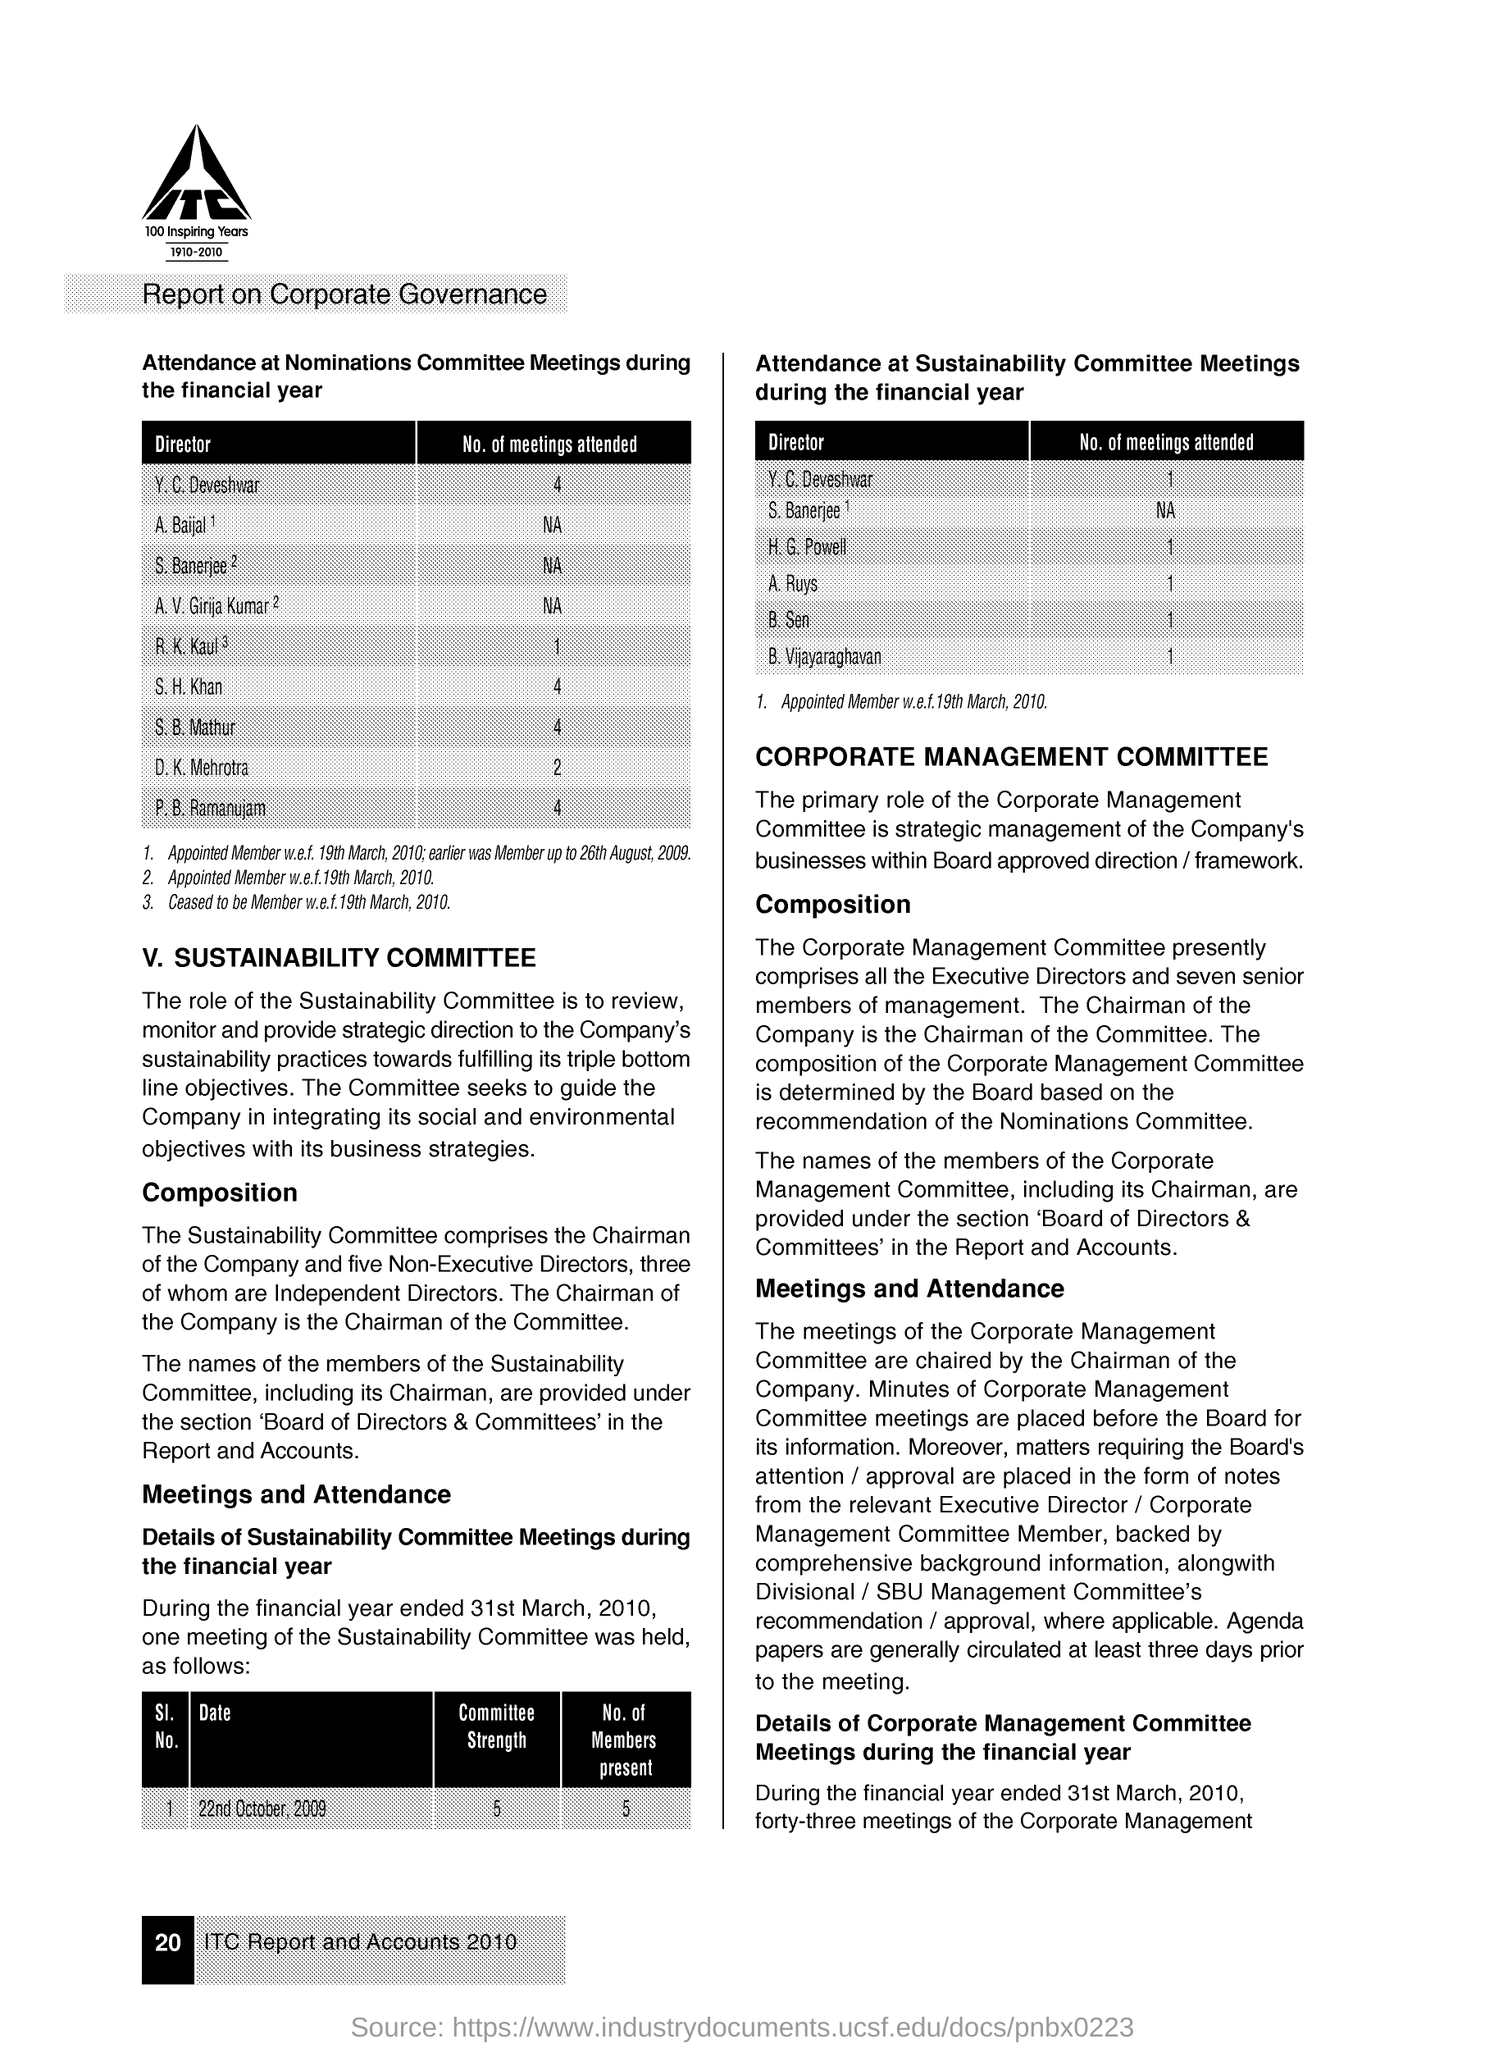Identify some key points in this picture. The title of the document is "Report on Corporate Governance." 